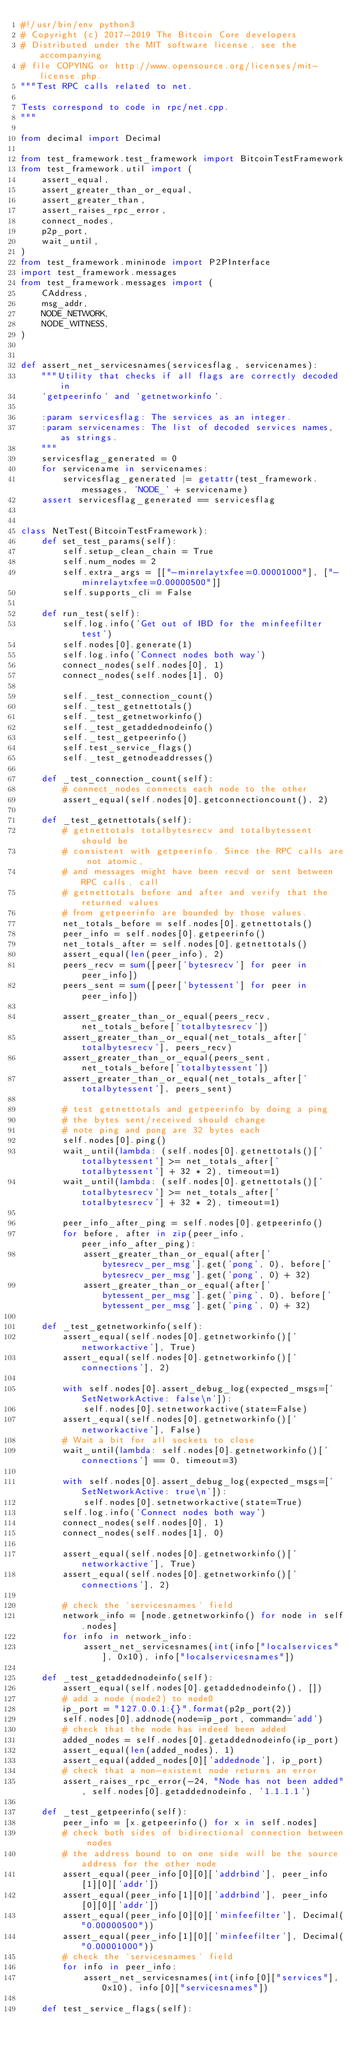<code> <loc_0><loc_0><loc_500><loc_500><_Python_>#!/usr/bin/env python3
# Copyright (c) 2017-2019 The Bitcoin Core developers
# Distributed under the MIT software license, see the accompanying
# file COPYING or http://www.opensource.org/licenses/mit-license.php.
"""Test RPC calls related to net.

Tests correspond to code in rpc/net.cpp.
"""

from decimal import Decimal

from test_framework.test_framework import BitcoinTestFramework
from test_framework.util import (
    assert_equal,
    assert_greater_than_or_equal,
    assert_greater_than,
    assert_raises_rpc_error,
    connect_nodes,
    p2p_port,
    wait_until,
)
from test_framework.mininode import P2PInterface
import test_framework.messages
from test_framework.messages import (
    CAddress,
    msg_addr,
    NODE_NETWORK,
    NODE_WITNESS,
)


def assert_net_servicesnames(servicesflag, servicenames):
    """Utility that checks if all flags are correctly decoded in
    `getpeerinfo` and `getnetworkinfo`.

    :param servicesflag: The services as an integer.
    :param servicenames: The list of decoded services names, as strings.
    """
    servicesflag_generated = 0
    for servicename in servicenames:
        servicesflag_generated |= getattr(test_framework.messages, 'NODE_' + servicename)
    assert servicesflag_generated == servicesflag


class NetTest(BitcoinTestFramework):
    def set_test_params(self):
        self.setup_clean_chain = True
        self.num_nodes = 2
        self.extra_args = [["-minrelaytxfee=0.00001000"], ["-minrelaytxfee=0.00000500"]]
        self.supports_cli = False

    def run_test(self):
        self.log.info('Get out of IBD for the minfeefilter test')
        self.nodes[0].generate(1)
        self.log.info('Connect nodes both way')
        connect_nodes(self.nodes[0], 1)
        connect_nodes(self.nodes[1], 0)

        self._test_connection_count()
        self._test_getnettotals()
        self._test_getnetworkinfo()
        self._test_getaddednodeinfo()
        self._test_getpeerinfo()
        self.test_service_flags()
        self._test_getnodeaddresses()

    def _test_connection_count(self):
        # connect_nodes connects each node to the other
        assert_equal(self.nodes[0].getconnectioncount(), 2)

    def _test_getnettotals(self):
        # getnettotals totalbytesrecv and totalbytessent should be
        # consistent with getpeerinfo. Since the RPC calls are not atomic,
        # and messages might have been recvd or sent between RPC calls, call
        # getnettotals before and after and verify that the returned values
        # from getpeerinfo are bounded by those values.
        net_totals_before = self.nodes[0].getnettotals()
        peer_info = self.nodes[0].getpeerinfo()
        net_totals_after = self.nodes[0].getnettotals()
        assert_equal(len(peer_info), 2)
        peers_recv = sum([peer['bytesrecv'] for peer in peer_info])
        peers_sent = sum([peer['bytessent'] for peer in peer_info])

        assert_greater_than_or_equal(peers_recv, net_totals_before['totalbytesrecv'])
        assert_greater_than_or_equal(net_totals_after['totalbytesrecv'], peers_recv)
        assert_greater_than_or_equal(peers_sent, net_totals_before['totalbytessent'])
        assert_greater_than_or_equal(net_totals_after['totalbytessent'], peers_sent)

        # test getnettotals and getpeerinfo by doing a ping
        # the bytes sent/received should change
        # note ping and pong are 32 bytes each
        self.nodes[0].ping()
        wait_until(lambda: (self.nodes[0].getnettotals()['totalbytessent'] >= net_totals_after['totalbytessent'] + 32 * 2), timeout=1)
        wait_until(lambda: (self.nodes[0].getnettotals()['totalbytesrecv'] >= net_totals_after['totalbytesrecv'] + 32 * 2), timeout=1)

        peer_info_after_ping = self.nodes[0].getpeerinfo()
        for before, after in zip(peer_info, peer_info_after_ping):
            assert_greater_than_or_equal(after['bytesrecv_per_msg'].get('pong', 0), before['bytesrecv_per_msg'].get('pong', 0) + 32)
            assert_greater_than_or_equal(after['bytessent_per_msg'].get('ping', 0), before['bytessent_per_msg'].get('ping', 0) + 32)

    def _test_getnetworkinfo(self):
        assert_equal(self.nodes[0].getnetworkinfo()['networkactive'], True)
        assert_equal(self.nodes[0].getnetworkinfo()['connections'], 2)

        with self.nodes[0].assert_debug_log(expected_msgs=['SetNetworkActive: false\n']):
            self.nodes[0].setnetworkactive(state=False)
        assert_equal(self.nodes[0].getnetworkinfo()['networkactive'], False)
        # Wait a bit for all sockets to close
        wait_until(lambda: self.nodes[0].getnetworkinfo()['connections'] == 0, timeout=3)

        with self.nodes[0].assert_debug_log(expected_msgs=['SetNetworkActive: true\n']):
            self.nodes[0].setnetworkactive(state=True)
        self.log.info('Connect nodes both way')
        connect_nodes(self.nodes[0], 1)
        connect_nodes(self.nodes[1], 0)

        assert_equal(self.nodes[0].getnetworkinfo()['networkactive'], True)
        assert_equal(self.nodes[0].getnetworkinfo()['connections'], 2)

        # check the `servicesnames` field
        network_info = [node.getnetworkinfo() for node in self.nodes]
        for info in network_info:
            assert_net_servicesnames(int(info["localservices"], 0x10), info["localservicesnames"])

    def _test_getaddednodeinfo(self):
        assert_equal(self.nodes[0].getaddednodeinfo(), [])
        # add a node (node2) to node0
        ip_port = "127.0.0.1:{}".format(p2p_port(2))
        self.nodes[0].addnode(node=ip_port, command='add')
        # check that the node has indeed been added
        added_nodes = self.nodes[0].getaddednodeinfo(ip_port)
        assert_equal(len(added_nodes), 1)
        assert_equal(added_nodes[0]['addednode'], ip_port)
        # check that a non-existent node returns an error
        assert_raises_rpc_error(-24, "Node has not been added", self.nodes[0].getaddednodeinfo, '1.1.1.1')

    def _test_getpeerinfo(self):
        peer_info = [x.getpeerinfo() for x in self.nodes]
        # check both sides of bidirectional connection between nodes
        # the address bound to on one side will be the source address for the other node
        assert_equal(peer_info[0][0]['addrbind'], peer_info[1][0]['addr'])
        assert_equal(peer_info[1][0]['addrbind'], peer_info[0][0]['addr'])
        assert_equal(peer_info[0][0]['minfeefilter'], Decimal("0.00000500"))
        assert_equal(peer_info[1][0]['minfeefilter'], Decimal("0.00001000"))
        # check the `servicesnames` field
        for info in peer_info:
            assert_net_servicesnames(int(info[0]["services"], 0x10), info[0]["servicesnames"])

    def test_service_flags(self):</code> 